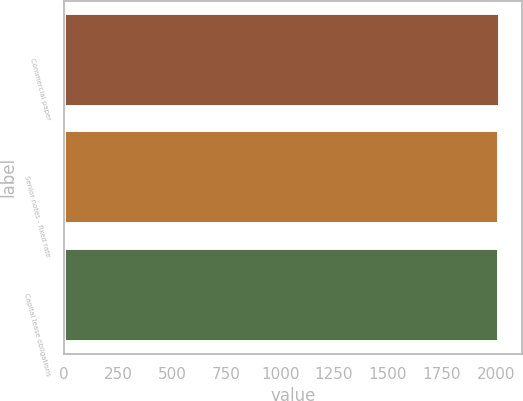Convert chart to OTSL. <chart><loc_0><loc_0><loc_500><loc_500><bar_chart><fcel>Commercial paper<fcel>Senior notes - fixed rate<fcel>Capital lease obligations<nl><fcel>2019<fcel>2015<fcel>2015.4<nl></chart> 